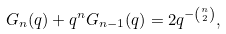Convert formula to latex. <formula><loc_0><loc_0><loc_500><loc_500>G _ { n } ( q ) + q ^ { n } G _ { n - 1 } ( q ) = 2 q ^ { - { n \choose 2 } } ,</formula> 